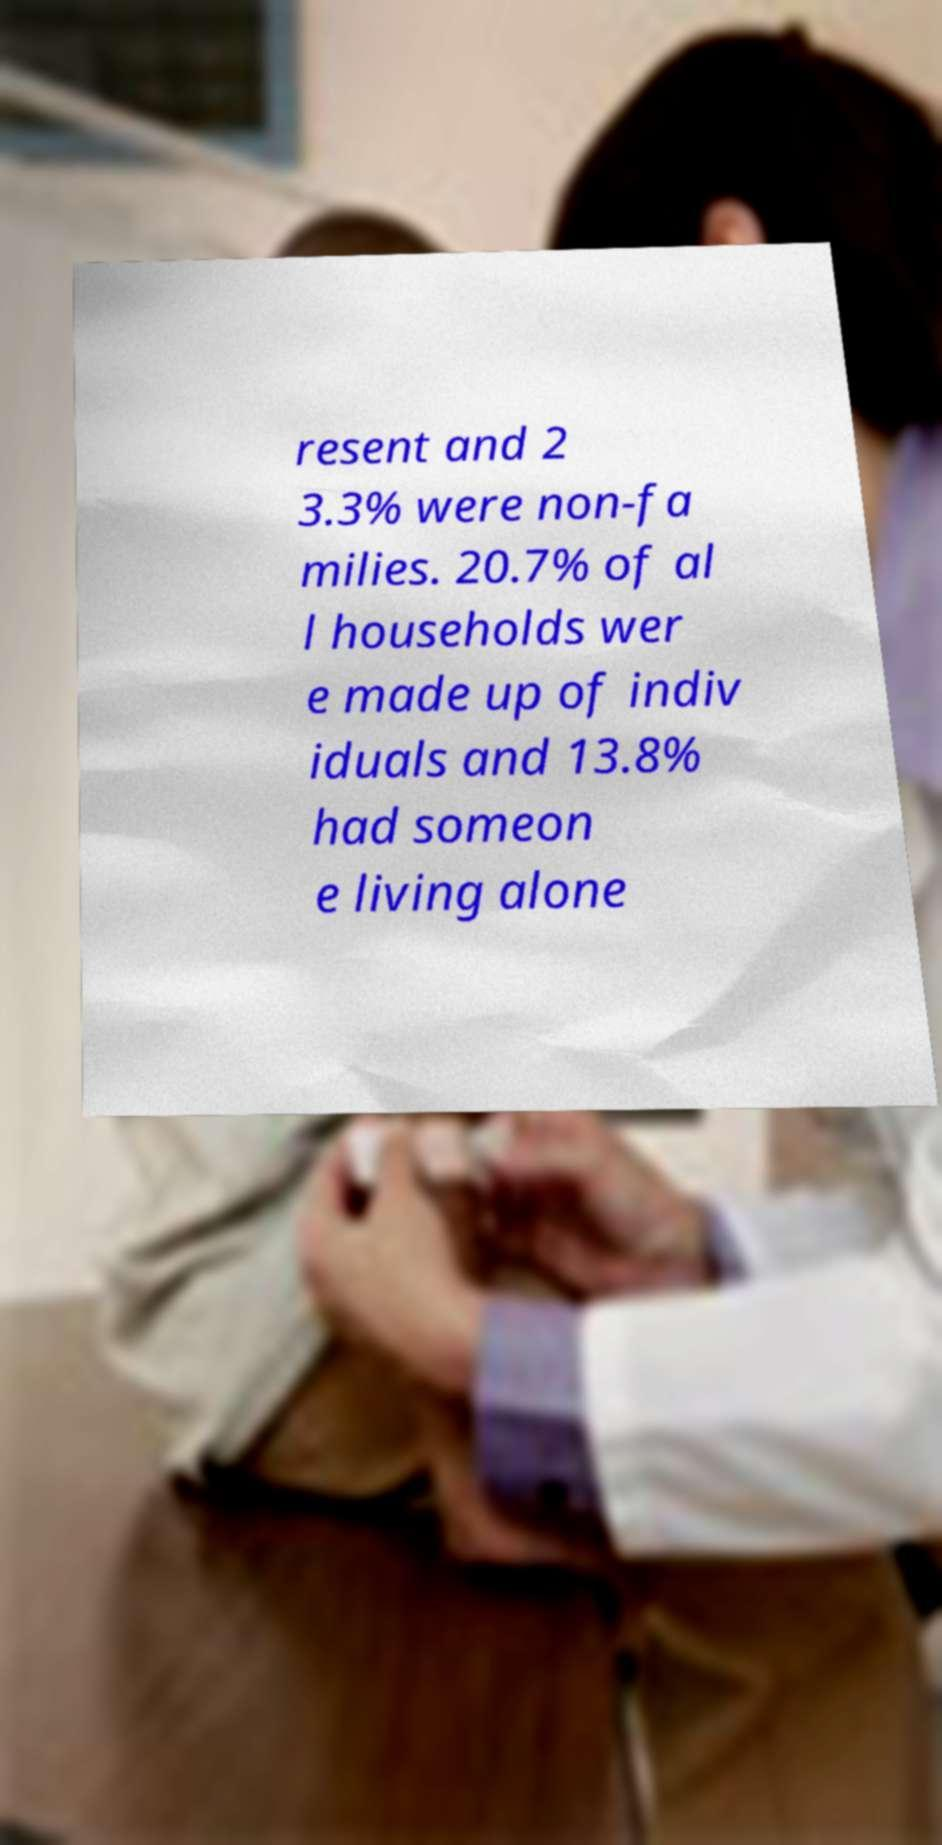I need the written content from this picture converted into text. Can you do that? resent and 2 3.3% were non-fa milies. 20.7% of al l households wer e made up of indiv iduals and 13.8% had someon e living alone 